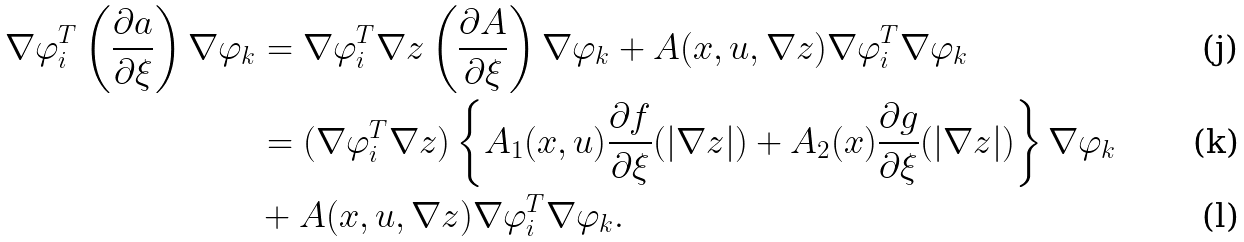Convert formula to latex. <formula><loc_0><loc_0><loc_500><loc_500>\nabla \varphi _ { i } ^ { T } \left ( \frac { \partial a } { \partial \xi } \right ) \nabla \varphi _ { k } & = \nabla \varphi _ { i } ^ { T } \nabla z \left ( \frac { \partial A } { \partial \xi } \right ) \nabla \varphi _ { k } + A ( x , u , \nabla z ) \nabla \varphi _ { i } ^ { T } \nabla \varphi _ { k } \\ & = ( \nabla \varphi _ { i } ^ { T } \nabla z ) \left \{ A _ { 1 } ( x , u ) \frac { \partial f } { \partial \xi } ( | \nabla z | ) + A _ { 2 } ( x ) \frac { \partial g } { \partial \xi } ( | \nabla z | ) \right \} \nabla \varphi _ { k } \\ & + A ( x , u , \nabla z ) \nabla \varphi _ { i } ^ { T } \nabla \varphi _ { k } .</formula> 